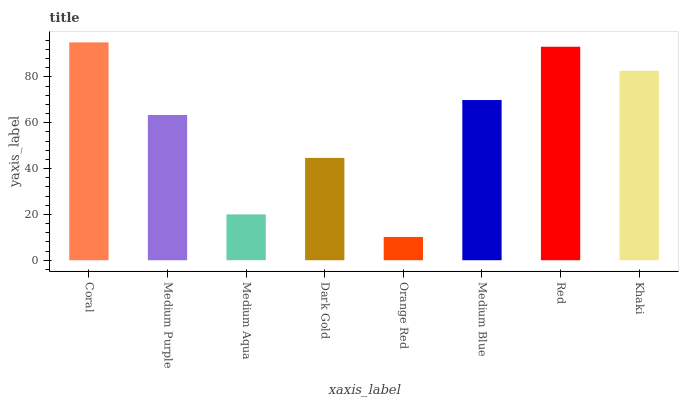Is Orange Red the minimum?
Answer yes or no. Yes. Is Coral the maximum?
Answer yes or no. Yes. Is Medium Purple the minimum?
Answer yes or no. No. Is Medium Purple the maximum?
Answer yes or no. No. Is Coral greater than Medium Purple?
Answer yes or no. Yes. Is Medium Purple less than Coral?
Answer yes or no. Yes. Is Medium Purple greater than Coral?
Answer yes or no. No. Is Coral less than Medium Purple?
Answer yes or no. No. Is Medium Blue the high median?
Answer yes or no. Yes. Is Medium Purple the low median?
Answer yes or no. Yes. Is Khaki the high median?
Answer yes or no. No. Is Red the low median?
Answer yes or no. No. 